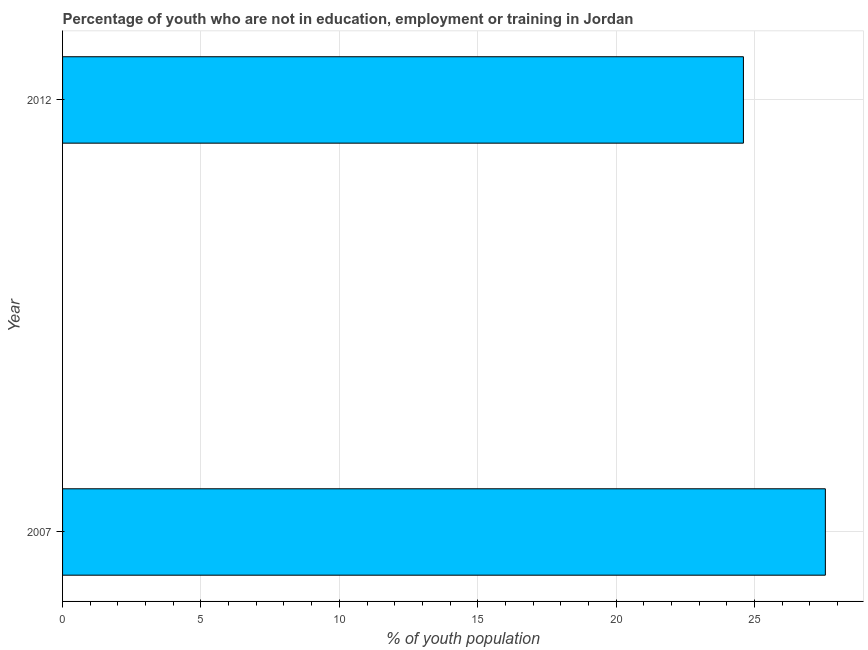What is the title of the graph?
Offer a terse response. Percentage of youth who are not in education, employment or training in Jordan. What is the label or title of the X-axis?
Offer a terse response. % of youth population. What is the unemployed youth population in 2012?
Provide a short and direct response. 24.6. Across all years, what is the maximum unemployed youth population?
Offer a terse response. 27.56. Across all years, what is the minimum unemployed youth population?
Keep it short and to the point. 24.6. In which year was the unemployed youth population minimum?
Ensure brevity in your answer.  2012. What is the sum of the unemployed youth population?
Provide a short and direct response. 52.16. What is the difference between the unemployed youth population in 2007 and 2012?
Ensure brevity in your answer.  2.96. What is the average unemployed youth population per year?
Your answer should be compact. 26.08. What is the median unemployed youth population?
Make the answer very short. 26.08. In how many years, is the unemployed youth population greater than 1 %?
Give a very brief answer. 2. What is the ratio of the unemployed youth population in 2007 to that in 2012?
Your answer should be compact. 1.12. In how many years, is the unemployed youth population greater than the average unemployed youth population taken over all years?
Give a very brief answer. 1. Are all the bars in the graph horizontal?
Offer a very short reply. Yes. Are the values on the major ticks of X-axis written in scientific E-notation?
Make the answer very short. No. What is the % of youth population of 2007?
Keep it short and to the point. 27.56. What is the % of youth population of 2012?
Your answer should be compact. 24.6. What is the difference between the % of youth population in 2007 and 2012?
Keep it short and to the point. 2.96. What is the ratio of the % of youth population in 2007 to that in 2012?
Offer a terse response. 1.12. 